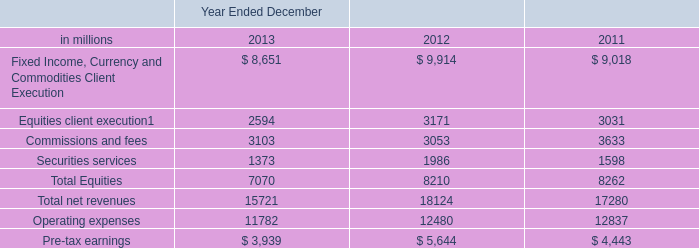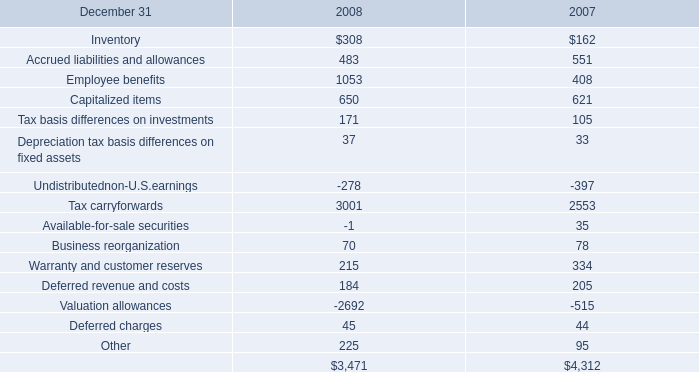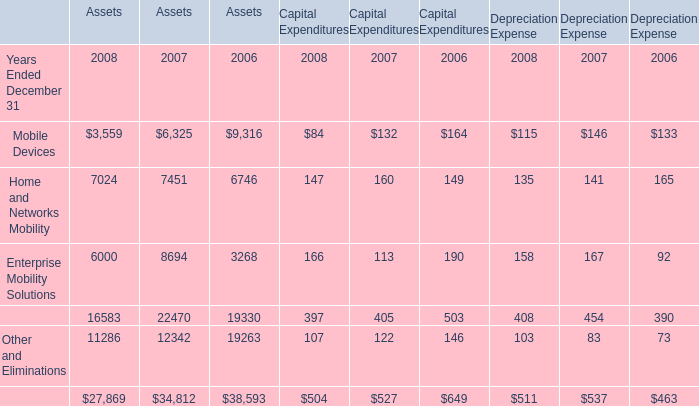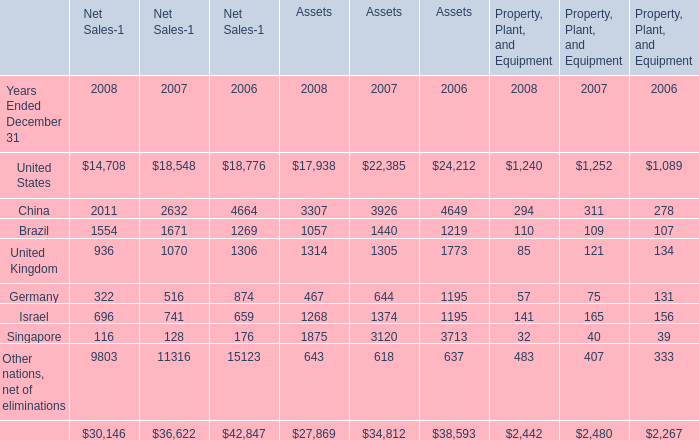In the year with lowest amount of United States, what's the increasing rate of China? 
Computations: ((((2011 + 3307) + 294) - ((2632 + 3926) + 311)) / ((2011 + 3307) + 294))
Answer: -0.22398. 